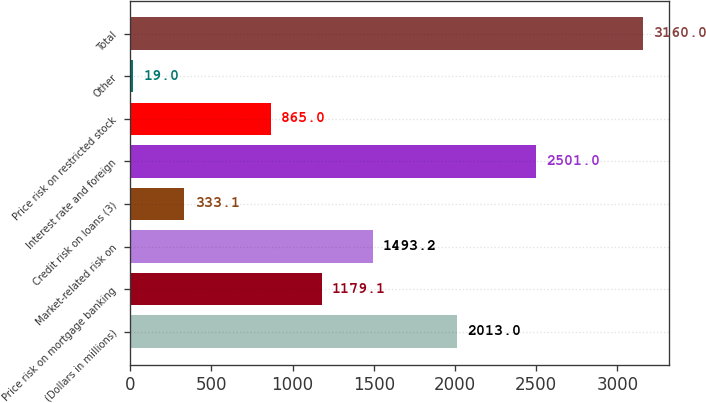Convert chart to OTSL. <chart><loc_0><loc_0><loc_500><loc_500><bar_chart><fcel>(Dollars in millions)<fcel>Price risk on mortgage banking<fcel>Market-related risk on<fcel>Credit risk on loans (3)<fcel>Interest rate and foreign<fcel>Price risk on restricted stock<fcel>Other<fcel>Total<nl><fcel>2013<fcel>1179.1<fcel>1493.2<fcel>333.1<fcel>2501<fcel>865<fcel>19<fcel>3160<nl></chart> 